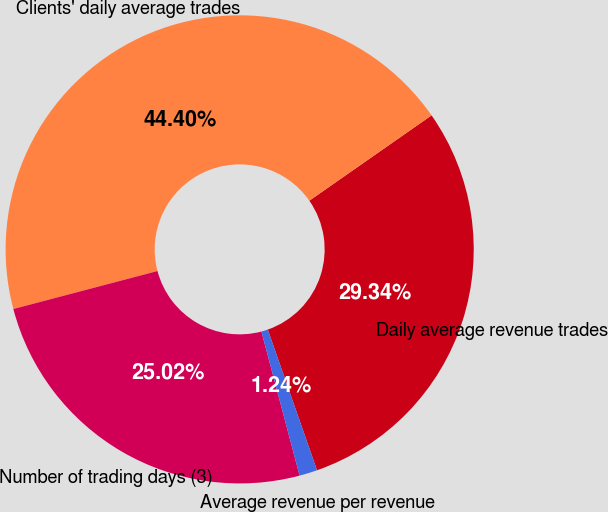Convert chart to OTSL. <chart><loc_0><loc_0><loc_500><loc_500><pie_chart><fcel>Daily average revenue trades<fcel>Clients' daily average trades<fcel>Number of trading days (3)<fcel>Average revenue per revenue<nl><fcel>29.34%<fcel>44.4%<fcel>25.02%<fcel>1.24%<nl></chart> 